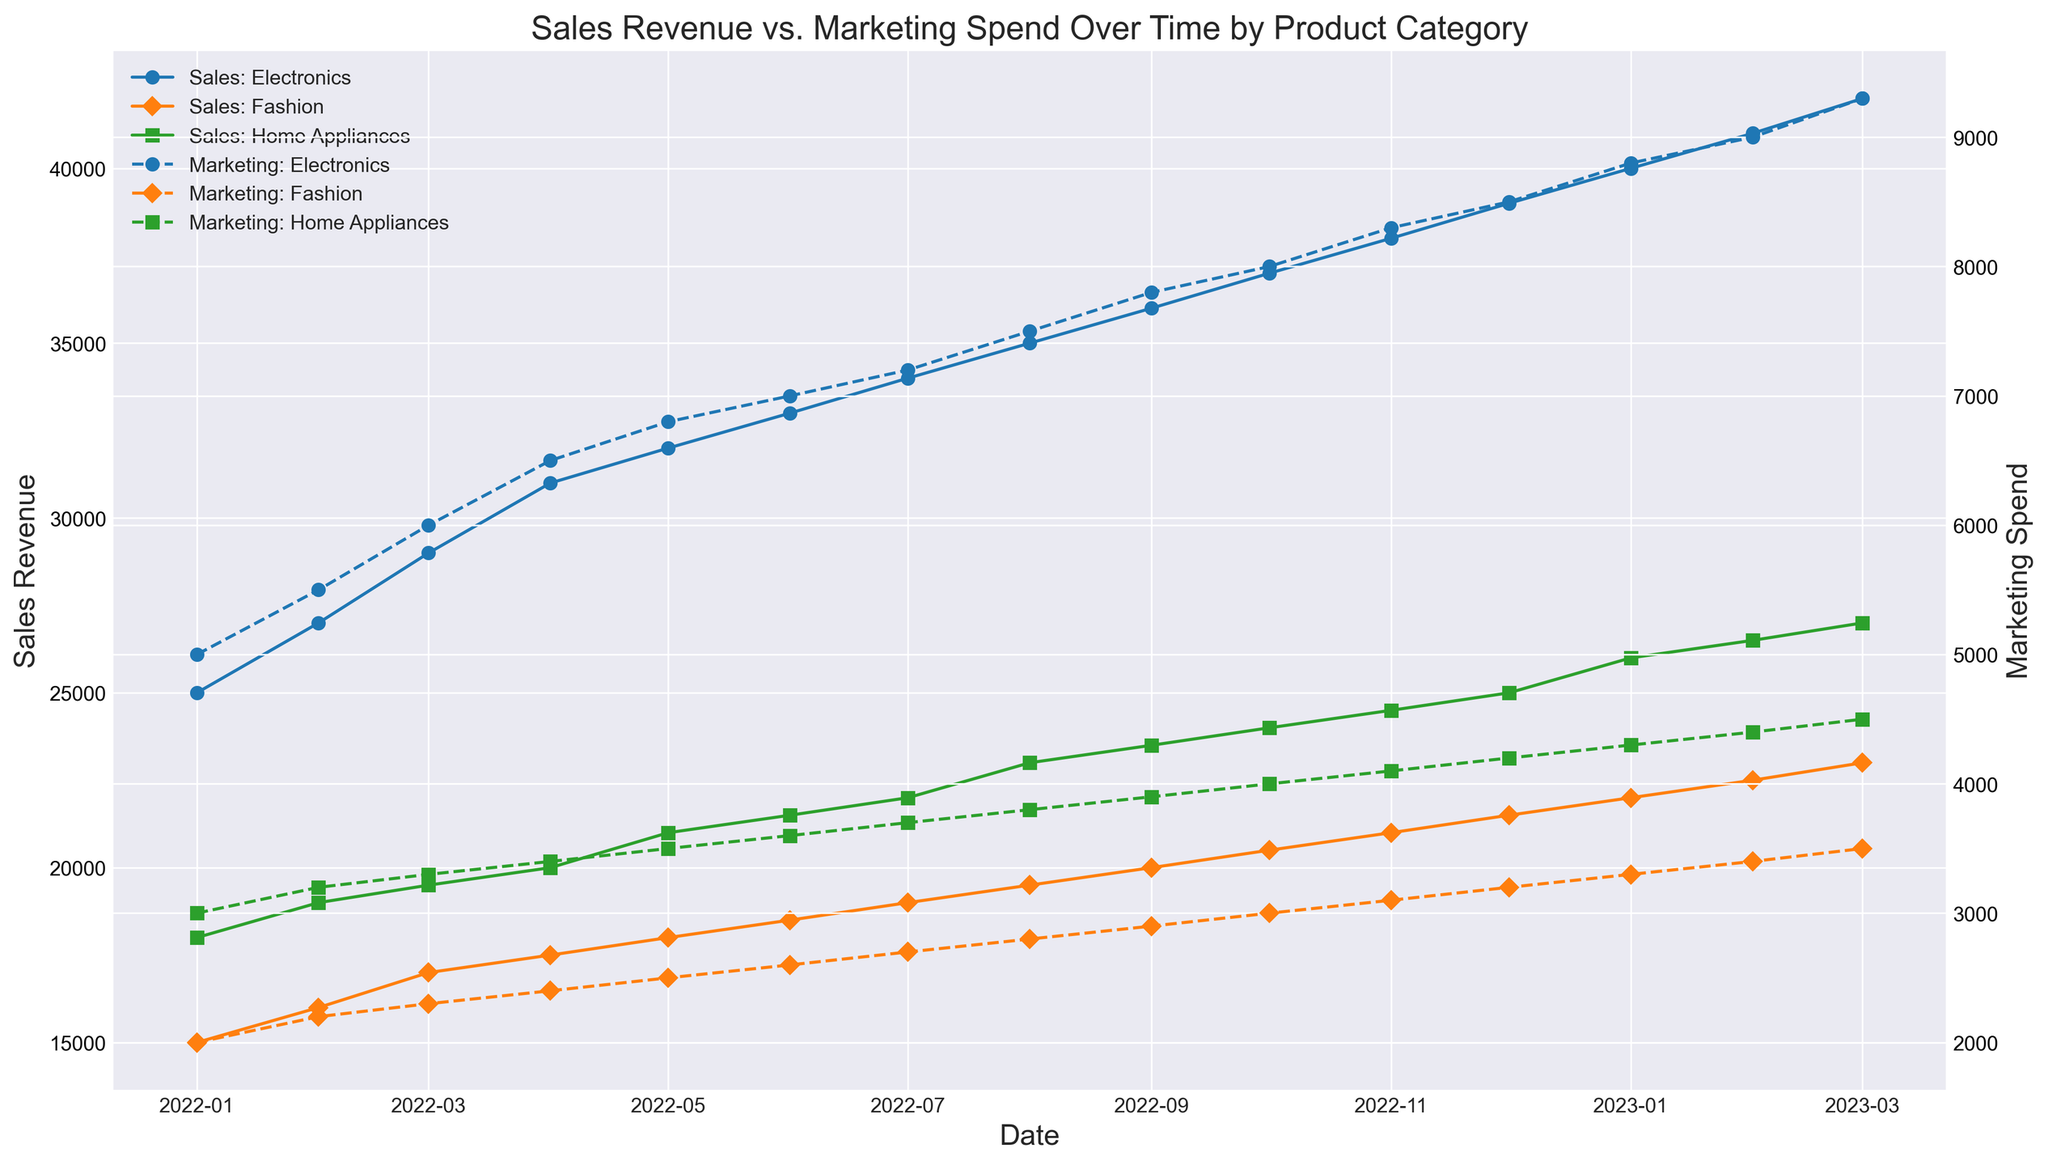What was the highest Sales Revenue for Electronics and when did it occur? By observing the plot for the line representing Electronics in Sales Revenue, we identify the highest point. The peak occurs at the end of the timeline in March 2023 with 42,000.
Answer: 42,000 in March 2023 Which product category had the highest Marketing Spend in January 2023, and how much was it? By checking the Marketing Spend lines for January 2023, the highest Marketing Spend can be seen in Electronics, with a value of 8,800.
Answer: Electronics with 8,800 What is the difference in Sales Revenue between Home Appliances and Fashion in February 2023? In February 2023, the Sales Revenue for Home Appliances is 19,000 and for Fashion is 16,000. The difference is 19,000 - 16,000 = 3,000.
Answer: 3,000 How did Marketing Spend for Fashion change from February 2022 to March 2022? The Marketing Spend for Fashion in February 2022 is 2,200 and in March 2022 is 2,300. The change is 2,300 - 2,200 = 100 increase.
Answer: increased by 100 When did Home Appliances reach a Sales Revenue of 26,000 and what was the Marketing Spend at that time? Home Appliances reached a Sales Revenue of 26,000 in January 2023, and the Marketing Spend at that time was 4,300.
Answer: January 2023 with 4,300 What is the total Marketing Spend for Electronics from January 2022 to March 2023? By looking at the Marketing Spend line for Electronics, summing the values from January 2022 (5,000, 5,500, 6,000, 6,500, 6,800, 7,000, 7,200, 7,500, 7,800, 8,000, 8,300, 8,500, 8,800, 9,000, 9,300), the total is 114,700.
Answer: 114,700 Which product category had the lowest Sales Revenue in December 2022, and what was the value? Observing the plot for December 2022, the Fashion line shows the lowest Sales Revenue with a value of 21,500.
Answer: Fashion with 21,500 Which month saw the biggest jump in Sales Revenue for Electronics, and what was the increase? From the Sales Revenue line of Electronics, the largest jump is between February 2023 (41,000) and March 2023 (42,000), an increase of 42,000 - 41,000 = 1,000.
Answer: February to March 2023 with an increase of 1,000 By how much did the Marketing Spend for Home Appliances increase from October 2022 to March 2023? Marketing Spend for Home Appliances in October 2022 is 4,000 and in March 2023 is 4,500. The increase is 4,500 - 4,000 = 500.
Answer: 500 What is the average Sales Revenue for Fashion from January 2022 to March 2023? Summing the Sales Revenues for Fashion (15,000, 16,000, 17,000, 17,500, 18,000, 18,500, 19,000, 19,500, 20,000, 20,500, 21,000, 21,500, 22,000, 22,500, 23,000) and dividing by the number of months (15), the average is (19,500) / 15 = 18,333.33.
Answer: 18,333.33 